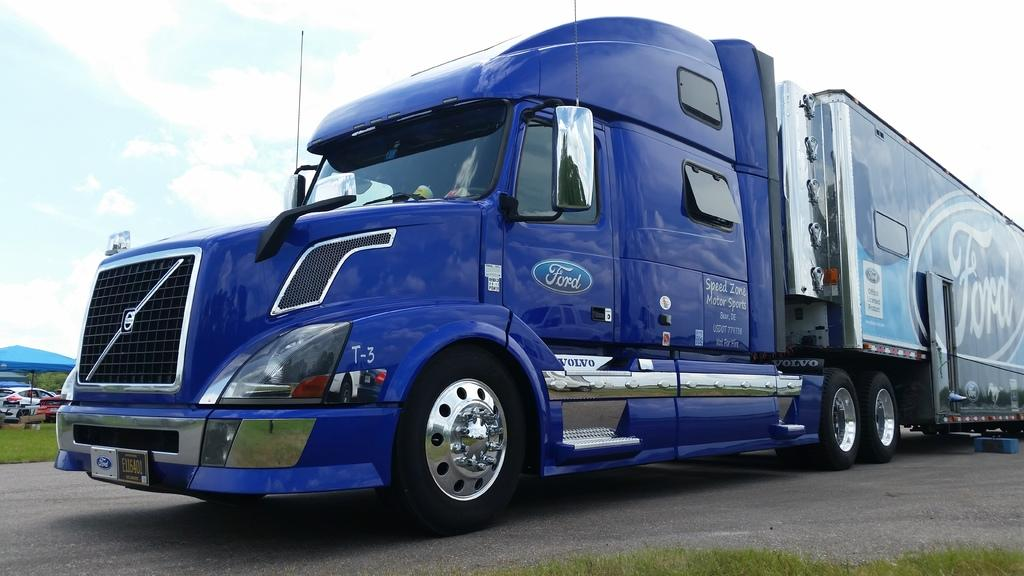What is on the road in the image? There is a vehicle on the road in the image. What type of vegetation can be seen in the image? There is grass visible in the image. How many cars are present in the image? There are cars in the image. What object is used for protection from rain in the image? There is an umbrella in the image. What is visible in the background of the image? The sky is visible in the background of the image. What can be observed in the sky? There are clouds in the sky. What type of feast is being prepared in the image? There is no feast present in the image; it features a vehicle on the road, grass, cars, an umbrella, and a sky with clouds. What word is written on the side of the vehicle in the image? There is no word visible on the side of the vehicle in the image. 